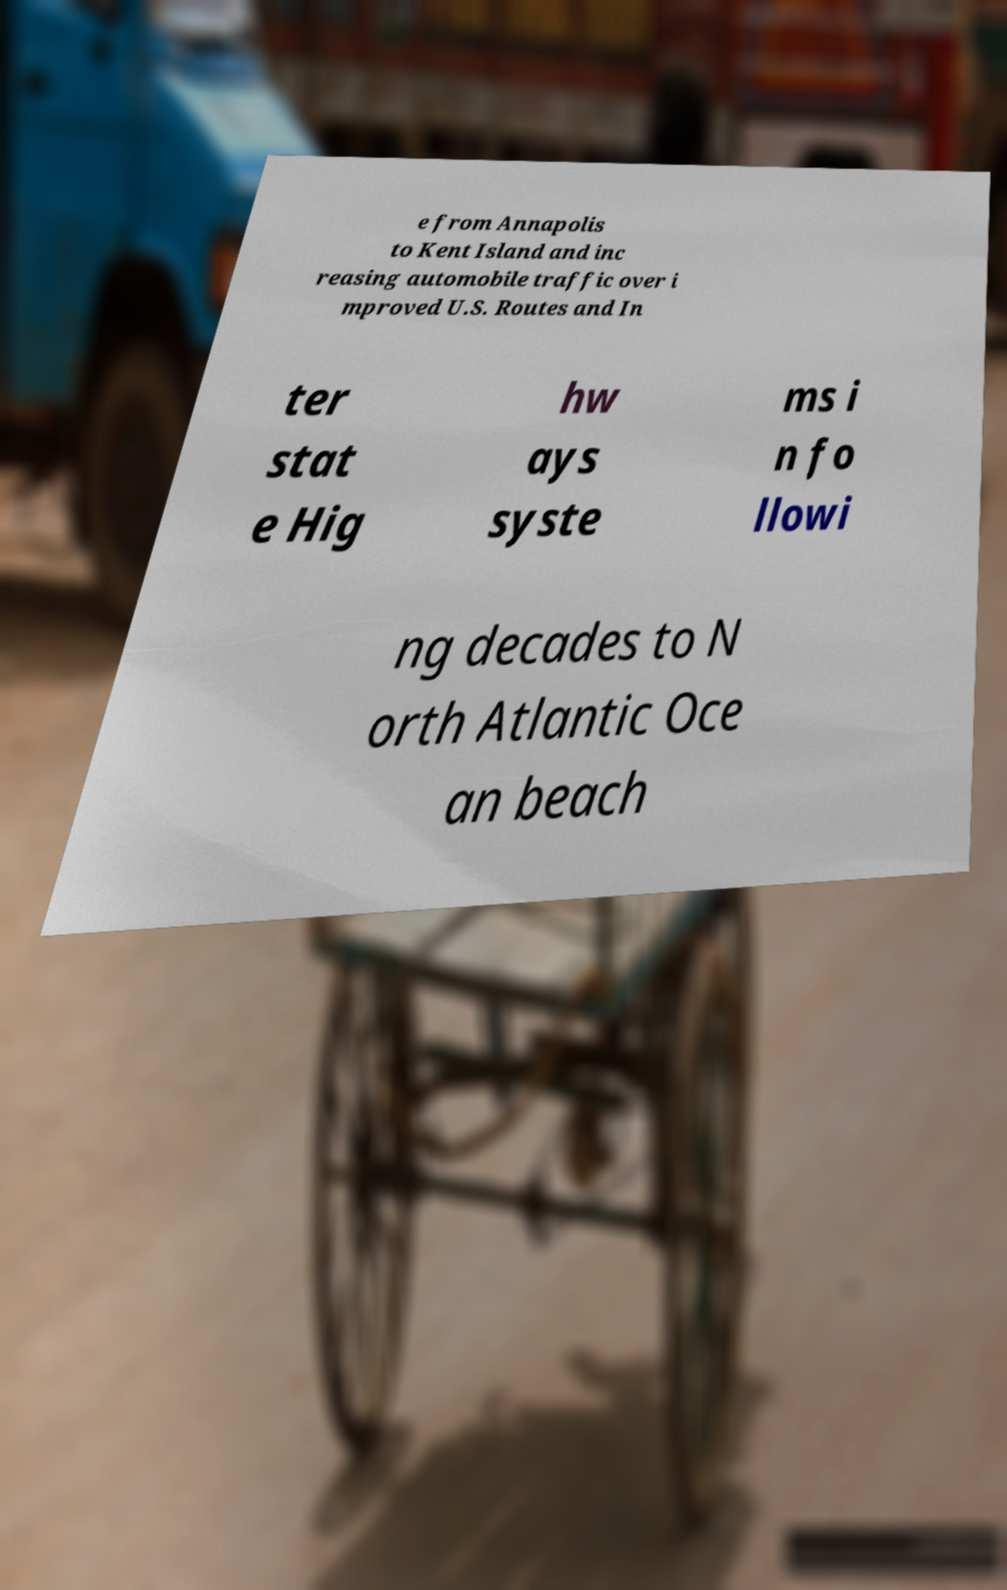Please read and relay the text visible in this image. What does it say? e from Annapolis to Kent Island and inc reasing automobile traffic over i mproved U.S. Routes and In ter stat e Hig hw ays syste ms i n fo llowi ng decades to N orth Atlantic Oce an beach 